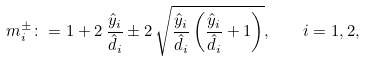Convert formula to latex. <formula><loc_0><loc_0><loc_500><loc_500>m _ { i } ^ { \pm } \colon = 1 + 2 \, \frac { \hat { y } _ { i } } { \hat { d } _ { i } } \pm 2 \, \sqrt { \frac { \hat { y } _ { i } } { \hat { d } _ { i } } \left ( \frac { \hat { y } _ { i } } { \hat { d } _ { i } } + 1 \right ) } , \quad i = 1 , 2 ,</formula> 